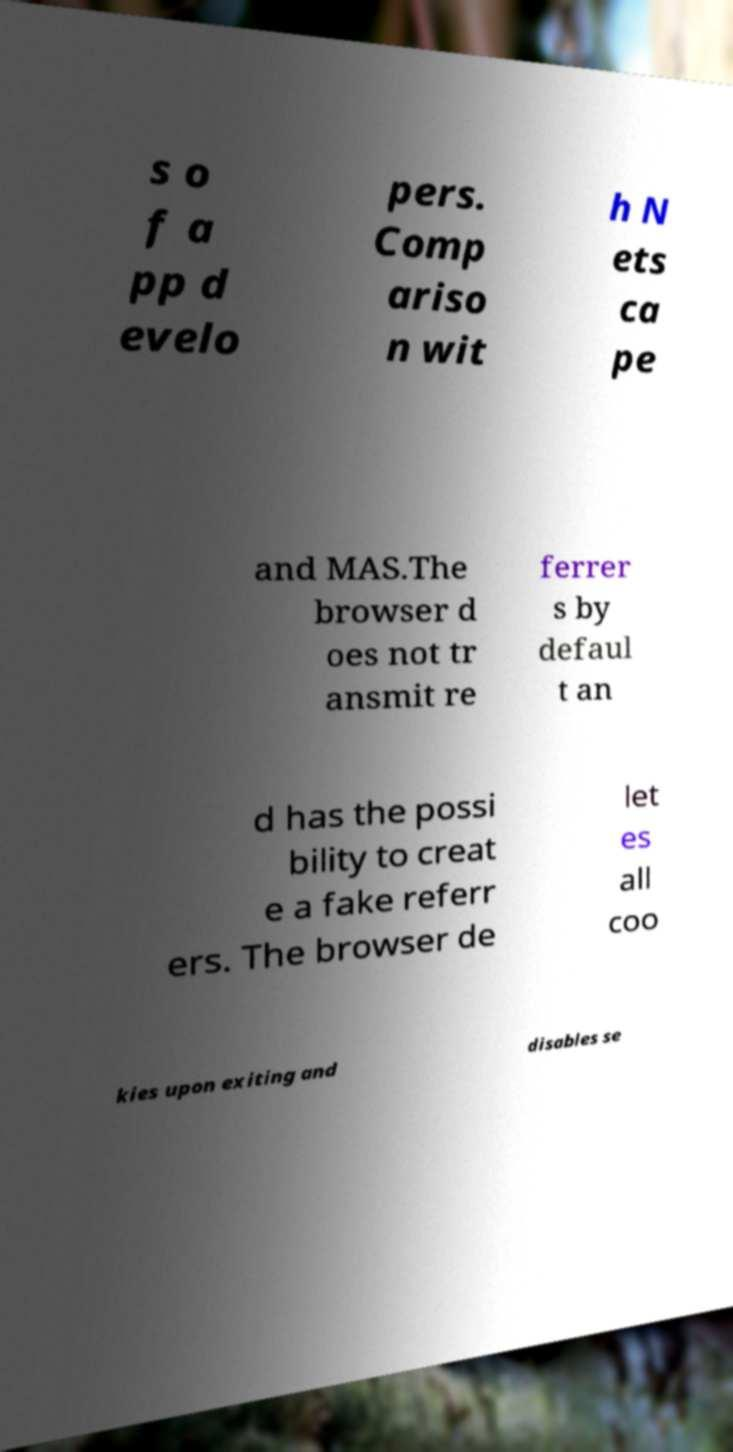What messages or text are displayed in this image? I need them in a readable, typed format. s o f a pp d evelo pers. Comp ariso n wit h N ets ca pe and MAS.The browser d oes not tr ansmit re ferrer s by defaul t an d has the possi bility to creat e a fake referr ers. The browser de let es all coo kies upon exiting and disables se 